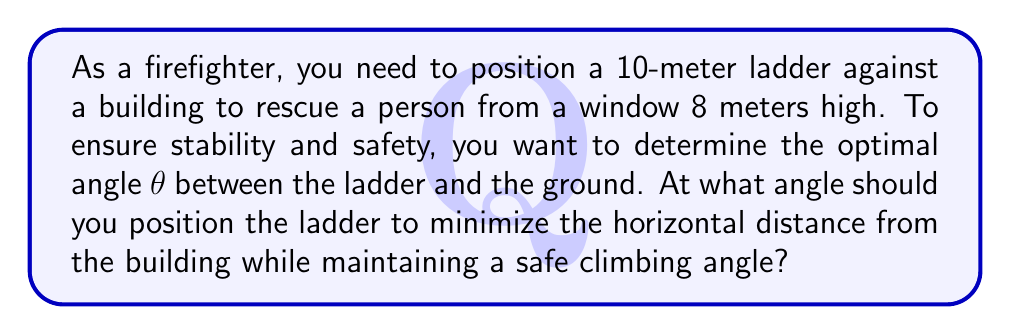Solve this math problem. Let's approach this step-by-step:

1) We can model this situation as a right triangle, where:
   - The ladder is the hypotenuse (10 m)
   - The height of the window is the opposite side (8 m)
   - The horizontal distance from the building is the adjacent side (let's call it x)

2) We want to minimize x while keeping θ within a safe range. Generally, a safe climbing angle is between 65° and 75°.

3) We can use the Pythagorean theorem to relate these sides:
   $$ x^2 + 8^2 = 10^2 $$

4) We can also use trigonometric ratios:
   $$ \sin θ = \frac{8}{10} = 0.8 $$
   $$ θ = \arcsin(0.8) ≈ 53.13° $$

5) However, this angle is too shallow for safe climbing. We need to increase it to at least 65°.

6) At 65°:
   $$ x = 10 \cos(65°) ≈ 4.23 \text{ m} $$

7) At 75°:
   $$ x = 10 \cos(75°) ≈ 2.59 \text{ m} $$

8) The optimal angle would be 75°, as it provides the smallest horizontal distance while still being within the safe climbing range.
Answer: 75° 